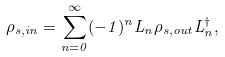Convert formula to latex. <formula><loc_0><loc_0><loc_500><loc_500>\rho _ { s , i n } = \sum _ { n = 0 } ^ { \infty } ( - 1 ) ^ { n } L _ { n } \rho _ { s , o u t } L _ { n } ^ { \dag } ,</formula> 